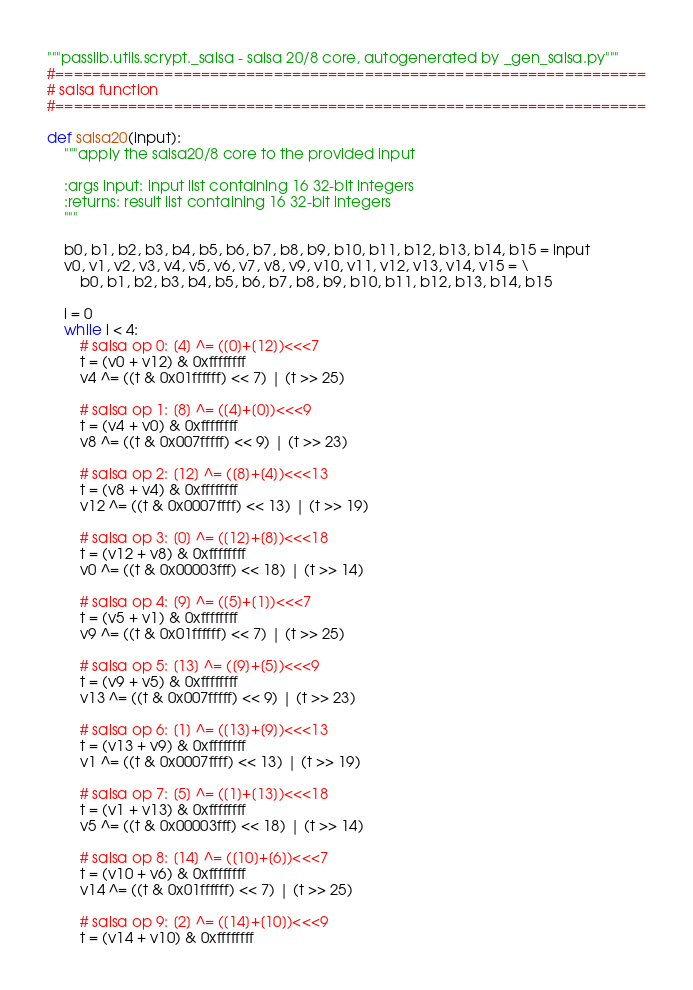Convert code to text. <code><loc_0><loc_0><loc_500><loc_500><_Python_>"""passlib.utils.scrypt._salsa - salsa 20/8 core, autogenerated by _gen_salsa.py"""
#=================================================================
# salsa function
#=================================================================

def salsa20(input):
    """apply the salsa20/8 core to the provided input

    :args input: input list containing 16 32-bit integers
    :returns: result list containing 16 32-bit integers
    """

    b0, b1, b2, b3, b4, b5, b6, b7, b8, b9, b10, b11, b12, b13, b14, b15 = input
    v0, v1, v2, v3, v4, v5, v6, v7, v8, v9, v10, v11, v12, v13, v14, v15 = \
        b0, b1, b2, b3, b4, b5, b6, b7, b8, b9, b10, b11, b12, b13, b14, b15

    i = 0
    while i < 4:
        # salsa op 0: [4] ^= ([0]+[12])<<<7
        t = (v0 + v12) & 0xffffffff
        v4 ^= ((t & 0x01ffffff) << 7) | (t >> 25)

        # salsa op 1: [8] ^= ([4]+[0])<<<9
        t = (v4 + v0) & 0xffffffff
        v8 ^= ((t & 0x007fffff) << 9) | (t >> 23)

        # salsa op 2: [12] ^= ([8]+[4])<<<13
        t = (v8 + v4) & 0xffffffff
        v12 ^= ((t & 0x0007ffff) << 13) | (t >> 19)

        # salsa op 3: [0] ^= ([12]+[8])<<<18
        t = (v12 + v8) & 0xffffffff
        v0 ^= ((t & 0x00003fff) << 18) | (t >> 14)

        # salsa op 4: [9] ^= ([5]+[1])<<<7
        t = (v5 + v1) & 0xffffffff
        v9 ^= ((t & 0x01ffffff) << 7) | (t >> 25)

        # salsa op 5: [13] ^= ([9]+[5])<<<9
        t = (v9 + v5) & 0xffffffff
        v13 ^= ((t & 0x007fffff) << 9) | (t >> 23)

        # salsa op 6: [1] ^= ([13]+[9])<<<13
        t = (v13 + v9) & 0xffffffff
        v1 ^= ((t & 0x0007ffff) << 13) | (t >> 19)

        # salsa op 7: [5] ^= ([1]+[13])<<<18
        t = (v1 + v13) & 0xffffffff
        v5 ^= ((t & 0x00003fff) << 18) | (t >> 14)

        # salsa op 8: [14] ^= ([10]+[6])<<<7
        t = (v10 + v6) & 0xffffffff
        v14 ^= ((t & 0x01ffffff) << 7) | (t >> 25)

        # salsa op 9: [2] ^= ([14]+[10])<<<9
        t = (v14 + v10) & 0xffffffff</code> 